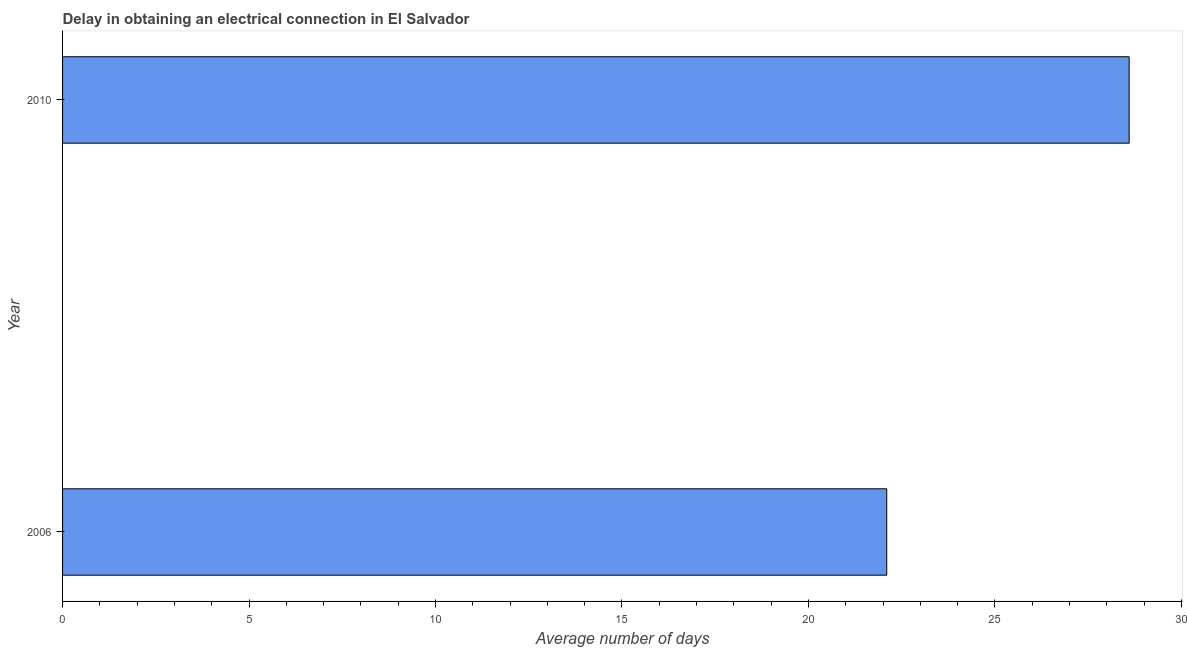What is the title of the graph?
Your answer should be compact. Delay in obtaining an electrical connection in El Salvador. What is the label or title of the X-axis?
Give a very brief answer. Average number of days. What is the label or title of the Y-axis?
Your response must be concise. Year. What is the dalay in electrical connection in 2006?
Offer a terse response. 22.1. Across all years, what is the maximum dalay in electrical connection?
Make the answer very short. 28.6. Across all years, what is the minimum dalay in electrical connection?
Offer a very short reply. 22.1. In which year was the dalay in electrical connection maximum?
Offer a very short reply. 2010. What is the sum of the dalay in electrical connection?
Provide a succinct answer. 50.7. What is the difference between the dalay in electrical connection in 2006 and 2010?
Offer a very short reply. -6.5. What is the average dalay in electrical connection per year?
Make the answer very short. 25.35. What is the median dalay in electrical connection?
Provide a short and direct response. 25.35. What is the ratio of the dalay in electrical connection in 2006 to that in 2010?
Give a very brief answer. 0.77. Is the dalay in electrical connection in 2006 less than that in 2010?
Provide a succinct answer. Yes. How many bars are there?
Provide a succinct answer. 2. Are the values on the major ticks of X-axis written in scientific E-notation?
Make the answer very short. No. What is the Average number of days in 2006?
Ensure brevity in your answer.  22.1. What is the Average number of days of 2010?
Your answer should be compact. 28.6. What is the ratio of the Average number of days in 2006 to that in 2010?
Make the answer very short. 0.77. 